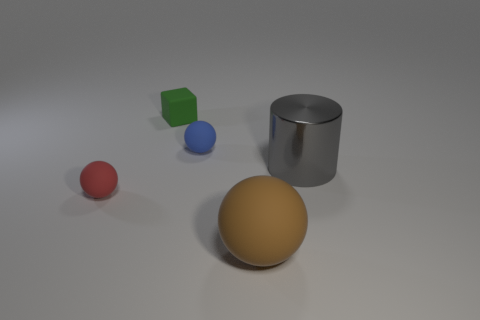Is the green object the same size as the gray shiny object?
Offer a very short reply. No. What is the gray thing made of?
Provide a short and direct response. Metal. What is the color of the large object that is made of the same material as the tiny green thing?
Provide a succinct answer. Brown. Do the red thing and the large thing that is on the left side of the gray shiny object have the same material?
Ensure brevity in your answer.  Yes. What number of red balls have the same material as the tiny green object?
Provide a succinct answer. 1. What is the shape of the brown thing to the right of the green rubber cube?
Your answer should be compact. Sphere. Is the small ball behind the shiny cylinder made of the same material as the large thing behind the red sphere?
Provide a short and direct response. No. Are there any other tiny objects that have the same shape as the brown matte thing?
Your response must be concise. Yes. What number of things are small spheres that are behind the small red object or big yellow cubes?
Provide a succinct answer. 1. Are there more small blue rubber spheres that are left of the large brown matte ball than big objects that are to the left of the green cube?
Your answer should be compact. Yes. 